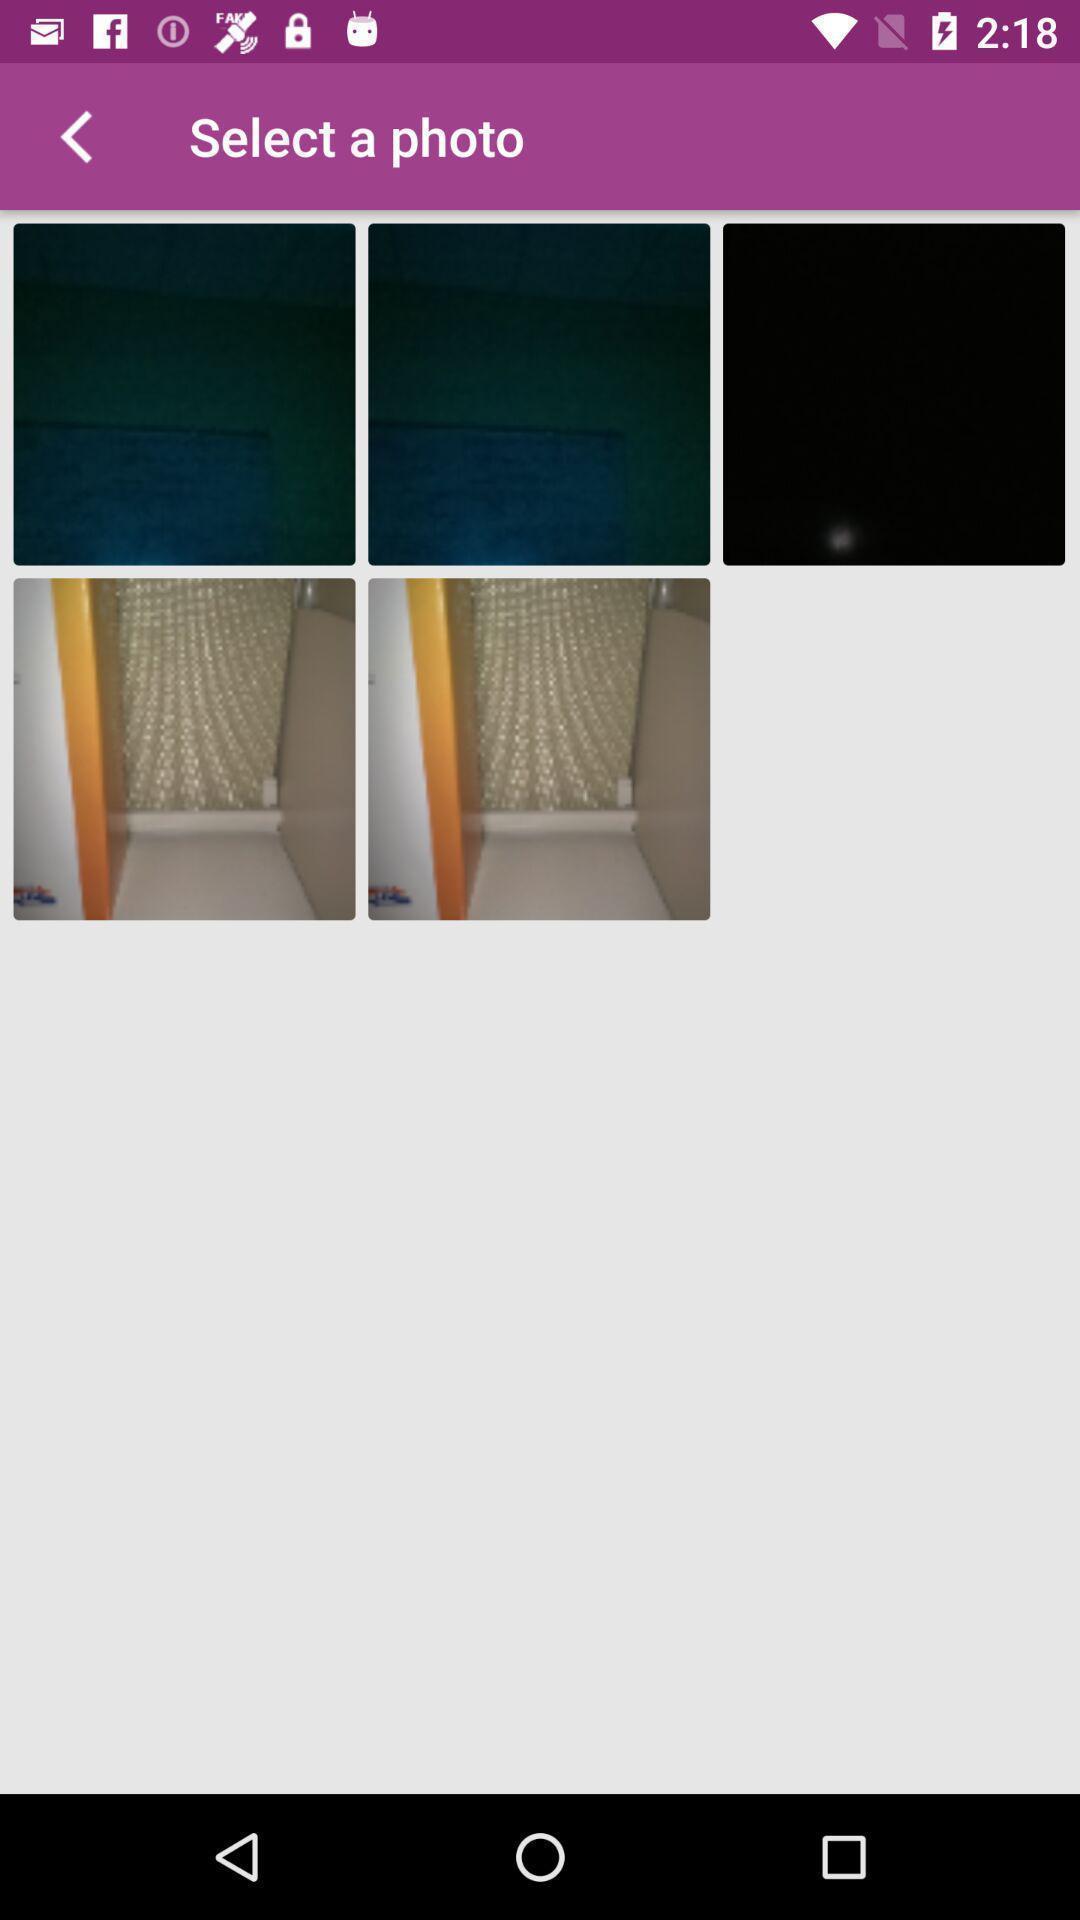Tell me about the visual elements in this screen capture. Select a photo from the photo app. 